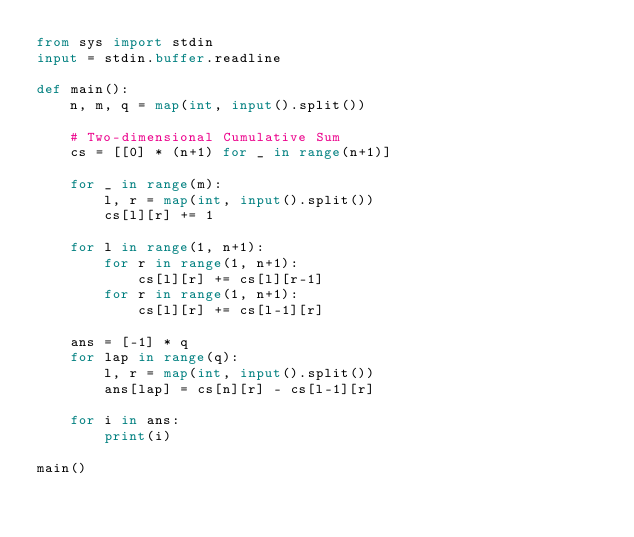<code> <loc_0><loc_0><loc_500><loc_500><_Python_>from sys import stdin
input = stdin.buffer.readline

def main():
    n, m, q = map(int, input().split())

    # Two-dimensional Cumulative Sum
    cs = [[0] * (n+1) for _ in range(n+1)]

    for _ in range(m):
        l, r = map(int, input().split())
        cs[l][r] += 1

    for l in range(1, n+1):
        for r in range(1, n+1):
            cs[l][r] += cs[l][r-1]
        for r in range(1, n+1):
            cs[l][r] += cs[l-1][r]

    ans = [-1] * q
    for lap in range(q):
        l, r = map(int, input().split())
        ans[lap] = cs[n][r] - cs[l-1][r]

    for i in ans:
        print(i)

main()</code> 